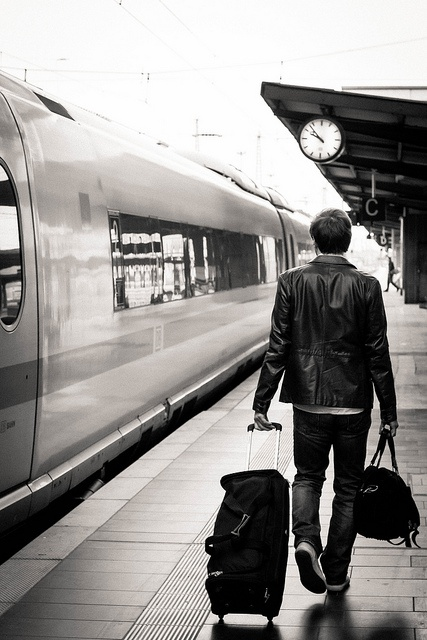Describe the objects in this image and their specific colors. I can see train in white, darkgray, lightgray, gray, and black tones, people in white, black, gray, darkgray, and lightgray tones, suitcase in white, black, lightgray, gray, and darkgray tones, handbag in white, black, darkgray, gray, and lightgray tones, and clock in white, darkgray, gray, and black tones in this image. 